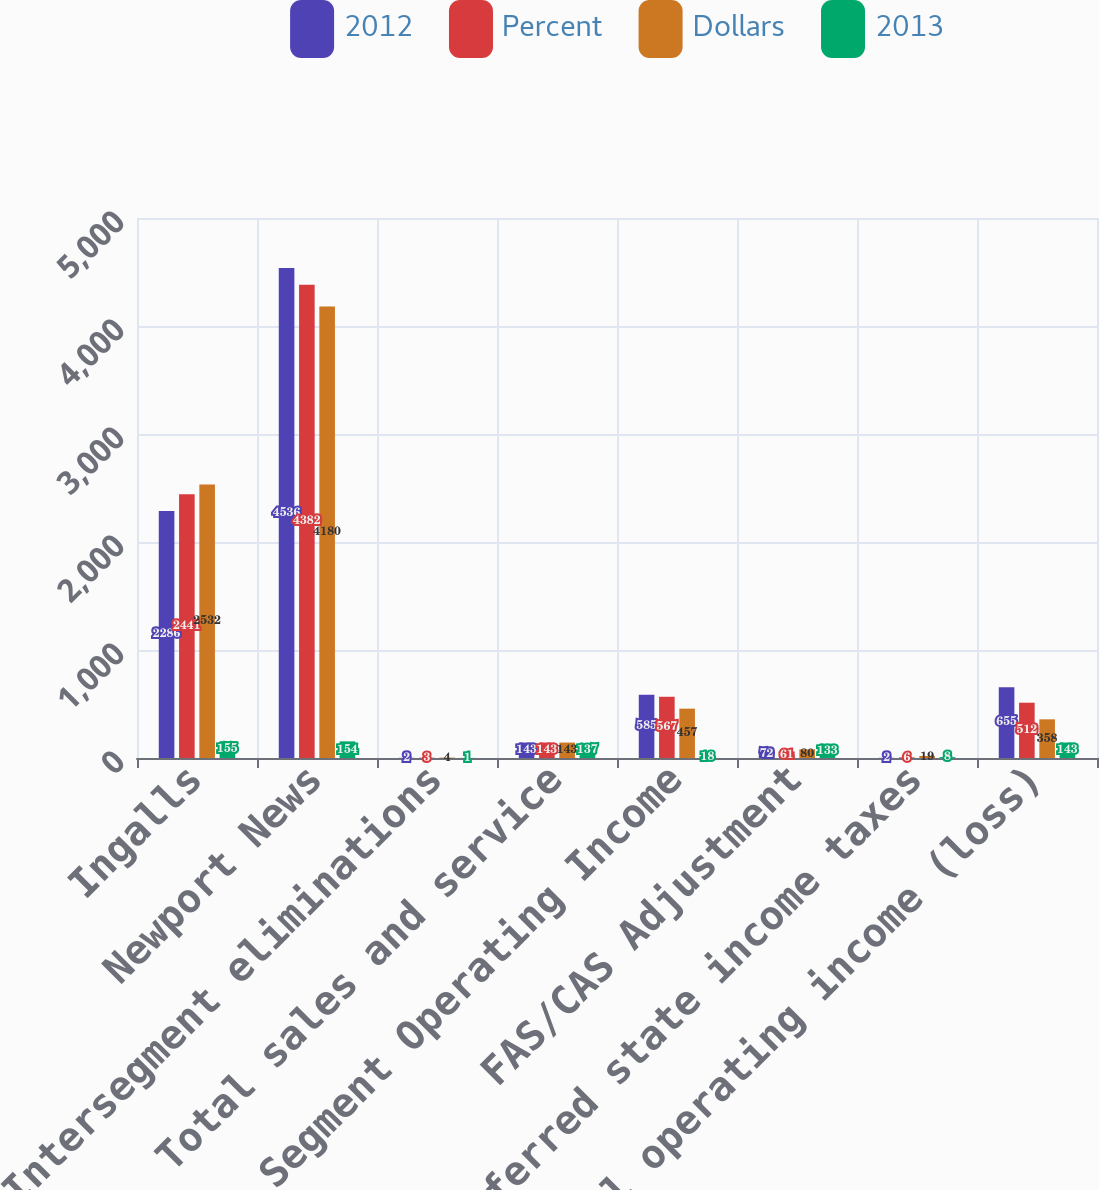<chart> <loc_0><loc_0><loc_500><loc_500><stacked_bar_chart><ecel><fcel>Ingalls<fcel>Newport News<fcel>Intersegment eliminations<fcel>Total sales and service<fcel>Total Segment Operating Income<fcel>FAS/CAS Adjustment<fcel>Deferred state income taxes<fcel>Total operating income (loss)<nl><fcel>2012<fcel>2286<fcel>4536<fcel>2<fcel>143<fcel>585<fcel>72<fcel>2<fcel>655<nl><fcel>Percent<fcel>2441<fcel>4382<fcel>3<fcel>143<fcel>567<fcel>61<fcel>6<fcel>512<nl><fcel>Dollars<fcel>2532<fcel>4180<fcel>4<fcel>143<fcel>457<fcel>80<fcel>19<fcel>358<nl><fcel>2013<fcel>155<fcel>154<fcel>1<fcel>137<fcel>18<fcel>133<fcel>8<fcel>143<nl></chart> 